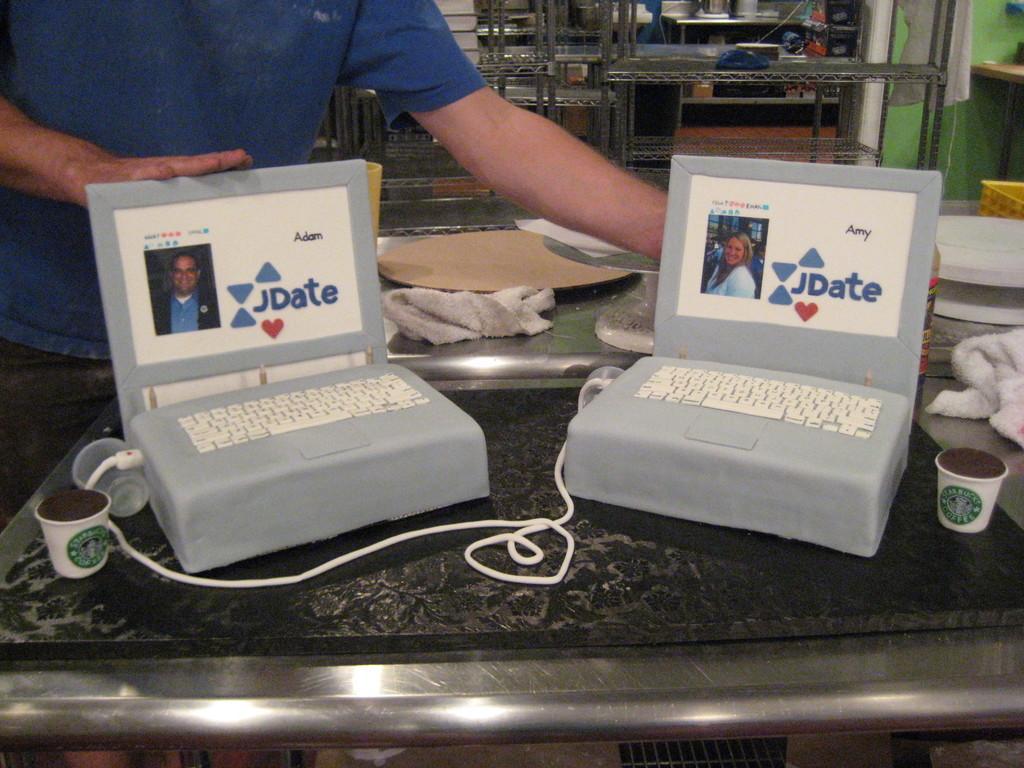Please provide a concise description of this image. Here there are laptops, here a man is standing, this is cup, cable, bottle, cloth is present. 